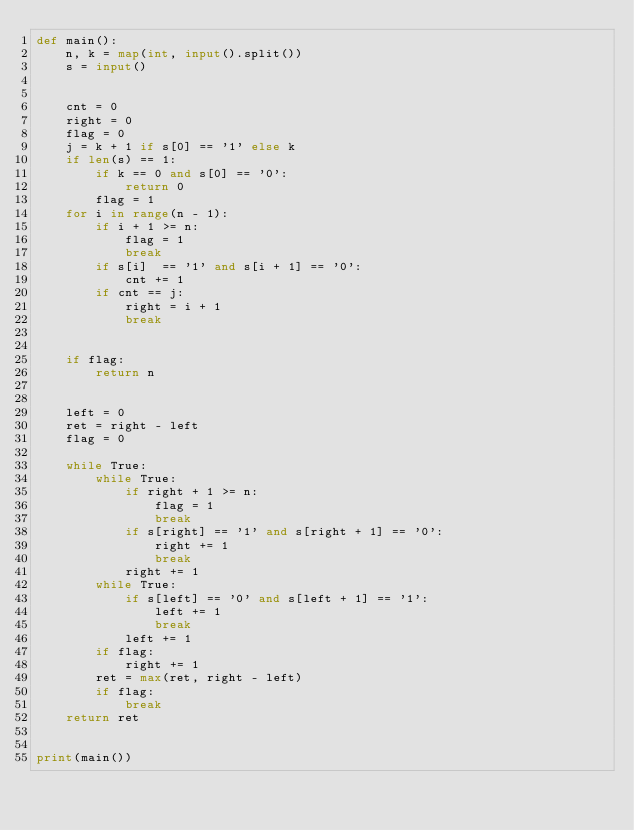Convert code to text. <code><loc_0><loc_0><loc_500><loc_500><_Python_>def main():
    n, k = map(int, input().split())
    s = input()


    cnt = 0
    right = 0
    flag = 0
    j = k + 1 if s[0] == '1' else k
    if len(s) == 1:
        if k == 0 and s[0] == '0':
            return 0
        flag = 1
    for i in range(n - 1):
        if i + 1 >= n:
            flag = 1
            break
        if s[i]  == '1' and s[i + 1] == '0':
            cnt += 1
        if cnt == j:
            right = i + 1
            break


    if flag:
        return n


    left = 0
    ret = right - left
    flag = 0

    while True:
        while True:
            if right + 1 >= n:
                flag = 1
                break
            if s[right] == '1' and s[right + 1] == '0':
                right += 1
                break
            right += 1
        while True:
            if s[left] == '0' and s[left + 1] == '1':
                left += 1
                break
            left += 1
        if flag:
            right += 1
        ret = max(ret, right - left)
        if flag:
            break
    return ret


print(main())</code> 